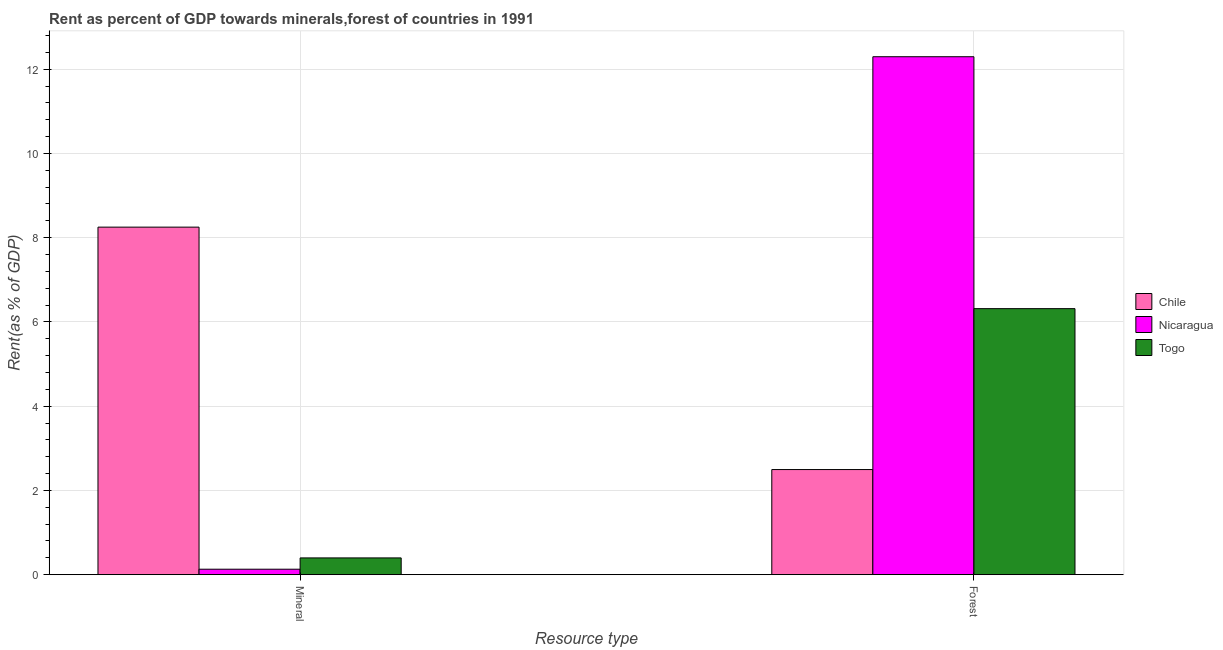How many different coloured bars are there?
Provide a short and direct response. 3. How many groups of bars are there?
Your answer should be very brief. 2. Are the number of bars per tick equal to the number of legend labels?
Keep it short and to the point. Yes. How many bars are there on the 1st tick from the left?
Give a very brief answer. 3. What is the label of the 2nd group of bars from the left?
Your response must be concise. Forest. What is the forest rent in Togo?
Make the answer very short. 6.32. Across all countries, what is the maximum mineral rent?
Make the answer very short. 8.25. Across all countries, what is the minimum forest rent?
Offer a terse response. 2.5. In which country was the mineral rent maximum?
Give a very brief answer. Chile. In which country was the forest rent minimum?
Give a very brief answer. Chile. What is the total forest rent in the graph?
Provide a succinct answer. 21.11. What is the difference between the forest rent in Chile and that in Togo?
Give a very brief answer. -3.82. What is the difference between the mineral rent in Chile and the forest rent in Nicaragua?
Give a very brief answer. -4.04. What is the average forest rent per country?
Your answer should be very brief. 7.04. What is the difference between the mineral rent and forest rent in Chile?
Your answer should be very brief. 5.75. What is the ratio of the forest rent in Chile to that in Togo?
Offer a very short reply. 0.4. In how many countries, is the forest rent greater than the average forest rent taken over all countries?
Ensure brevity in your answer.  1. What does the 3rd bar from the left in Mineral represents?
Offer a terse response. Togo. What does the 1st bar from the right in Mineral represents?
Your response must be concise. Togo. How many bars are there?
Keep it short and to the point. 6. Are all the bars in the graph horizontal?
Ensure brevity in your answer.  No. Are the values on the major ticks of Y-axis written in scientific E-notation?
Your answer should be compact. No. Does the graph contain any zero values?
Make the answer very short. No. How many legend labels are there?
Keep it short and to the point. 3. What is the title of the graph?
Offer a very short reply. Rent as percent of GDP towards minerals,forest of countries in 1991. What is the label or title of the X-axis?
Give a very brief answer. Resource type. What is the label or title of the Y-axis?
Offer a terse response. Rent(as % of GDP). What is the Rent(as % of GDP) in Chile in Mineral?
Your response must be concise. 8.25. What is the Rent(as % of GDP) of Nicaragua in Mineral?
Ensure brevity in your answer.  0.13. What is the Rent(as % of GDP) of Togo in Mineral?
Your answer should be very brief. 0.4. What is the Rent(as % of GDP) of Chile in Forest?
Give a very brief answer. 2.5. What is the Rent(as % of GDP) of Nicaragua in Forest?
Your answer should be very brief. 12.3. What is the Rent(as % of GDP) in Togo in Forest?
Your response must be concise. 6.32. Across all Resource type, what is the maximum Rent(as % of GDP) in Chile?
Your response must be concise. 8.25. Across all Resource type, what is the maximum Rent(as % of GDP) of Nicaragua?
Give a very brief answer. 12.3. Across all Resource type, what is the maximum Rent(as % of GDP) of Togo?
Your answer should be compact. 6.32. Across all Resource type, what is the minimum Rent(as % of GDP) in Chile?
Your answer should be very brief. 2.5. Across all Resource type, what is the minimum Rent(as % of GDP) of Nicaragua?
Your response must be concise. 0.13. Across all Resource type, what is the minimum Rent(as % of GDP) of Togo?
Ensure brevity in your answer.  0.4. What is the total Rent(as % of GDP) of Chile in the graph?
Keep it short and to the point. 10.75. What is the total Rent(as % of GDP) of Nicaragua in the graph?
Make the answer very short. 12.43. What is the total Rent(as % of GDP) of Togo in the graph?
Provide a short and direct response. 6.71. What is the difference between the Rent(as % of GDP) in Chile in Mineral and that in Forest?
Provide a short and direct response. 5.75. What is the difference between the Rent(as % of GDP) of Nicaragua in Mineral and that in Forest?
Offer a very short reply. -12.17. What is the difference between the Rent(as % of GDP) in Togo in Mineral and that in Forest?
Keep it short and to the point. -5.92. What is the difference between the Rent(as % of GDP) in Chile in Mineral and the Rent(as % of GDP) in Nicaragua in Forest?
Your answer should be very brief. -4.04. What is the difference between the Rent(as % of GDP) in Chile in Mineral and the Rent(as % of GDP) in Togo in Forest?
Make the answer very short. 1.94. What is the difference between the Rent(as % of GDP) of Nicaragua in Mineral and the Rent(as % of GDP) of Togo in Forest?
Provide a short and direct response. -6.19. What is the average Rent(as % of GDP) of Chile per Resource type?
Provide a succinct answer. 5.37. What is the average Rent(as % of GDP) of Nicaragua per Resource type?
Offer a very short reply. 6.21. What is the average Rent(as % of GDP) of Togo per Resource type?
Make the answer very short. 3.36. What is the difference between the Rent(as % of GDP) of Chile and Rent(as % of GDP) of Nicaragua in Mineral?
Offer a very short reply. 8.12. What is the difference between the Rent(as % of GDP) of Chile and Rent(as % of GDP) of Togo in Mineral?
Your answer should be very brief. 7.85. What is the difference between the Rent(as % of GDP) of Nicaragua and Rent(as % of GDP) of Togo in Mineral?
Provide a succinct answer. -0.27. What is the difference between the Rent(as % of GDP) of Chile and Rent(as % of GDP) of Nicaragua in Forest?
Offer a very short reply. -9.8. What is the difference between the Rent(as % of GDP) in Chile and Rent(as % of GDP) in Togo in Forest?
Your answer should be very brief. -3.82. What is the difference between the Rent(as % of GDP) of Nicaragua and Rent(as % of GDP) of Togo in Forest?
Give a very brief answer. 5.98. What is the ratio of the Rent(as % of GDP) in Chile in Mineral to that in Forest?
Offer a very short reply. 3.31. What is the ratio of the Rent(as % of GDP) of Nicaragua in Mineral to that in Forest?
Your response must be concise. 0.01. What is the ratio of the Rent(as % of GDP) of Togo in Mineral to that in Forest?
Make the answer very short. 0.06. What is the difference between the highest and the second highest Rent(as % of GDP) in Chile?
Your answer should be compact. 5.75. What is the difference between the highest and the second highest Rent(as % of GDP) in Nicaragua?
Provide a succinct answer. 12.17. What is the difference between the highest and the second highest Rent(as % of GDP) in Togo?
Offer a very short reply. 5.92. What is the difference between the highest and the lowest Rent(as % of GDP) in Chile?
Make the answer very short. 5.75. What is the difference between the highest and the lowest Rent(as % of GDP) in Nicaragua?
Give a very brief answer. 12.17. What is the difference between the highest and the lowest Rent(as % of GDP) in Togo?
Offer a very short reply. 5.92. 